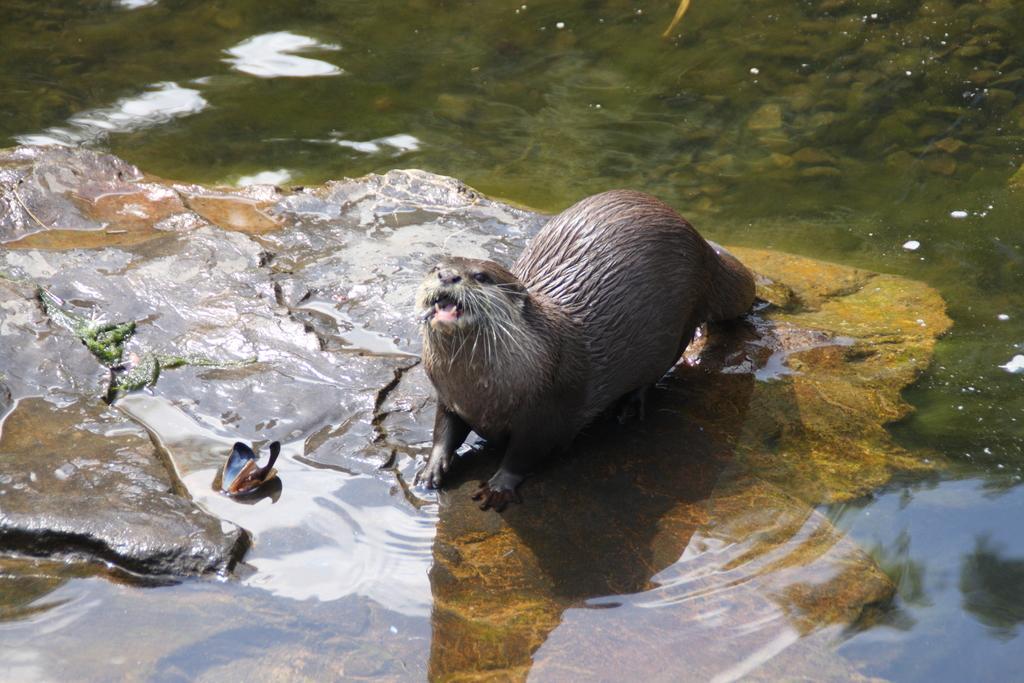Describe this image in one or two sentences. In the picture there is a seal on a rockin around the seal there is a lot of water. 